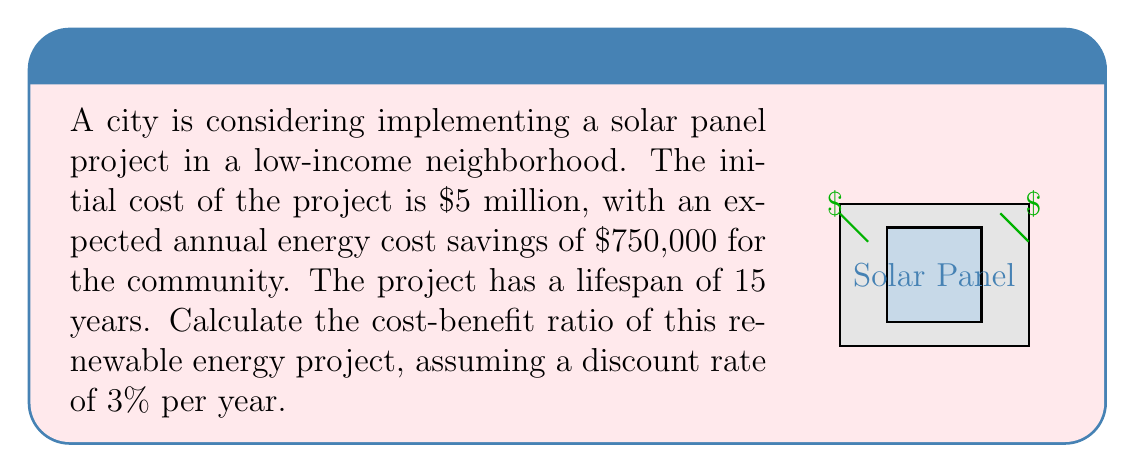Teach me how to tackle this problem. To calculate the cost-benefit ratio, we need to:

1. Calculate the Present Value (PV) of benefits:
   Annual benefit = $750,000
   Number of years = 15
   Discount rate = 3% = 0.03

   Using the Present Value of Annuity formula:
   $$PV = A \cdot \frac{1-(1+r)^{-n}}{r}$$
   Where A = annual benefit, r = discount rate, n = number of years

   $$PV = 750000 \cdot \frac{1-(1+0.03)^{-15}}{0.03} = 8,768,290.76$$

2. Calculate the cost-benefit ratio:
   $$\text{Cost-Benefit Ratio} = \frac{\text{Present Value of Benefits}}{\text{Initial Cost}}$$
   
   $$\text{Cost-Benefit Ratio} = \frac{8,768,290.76}{5,000,000} = 1.75$$
Answer: 1.75 